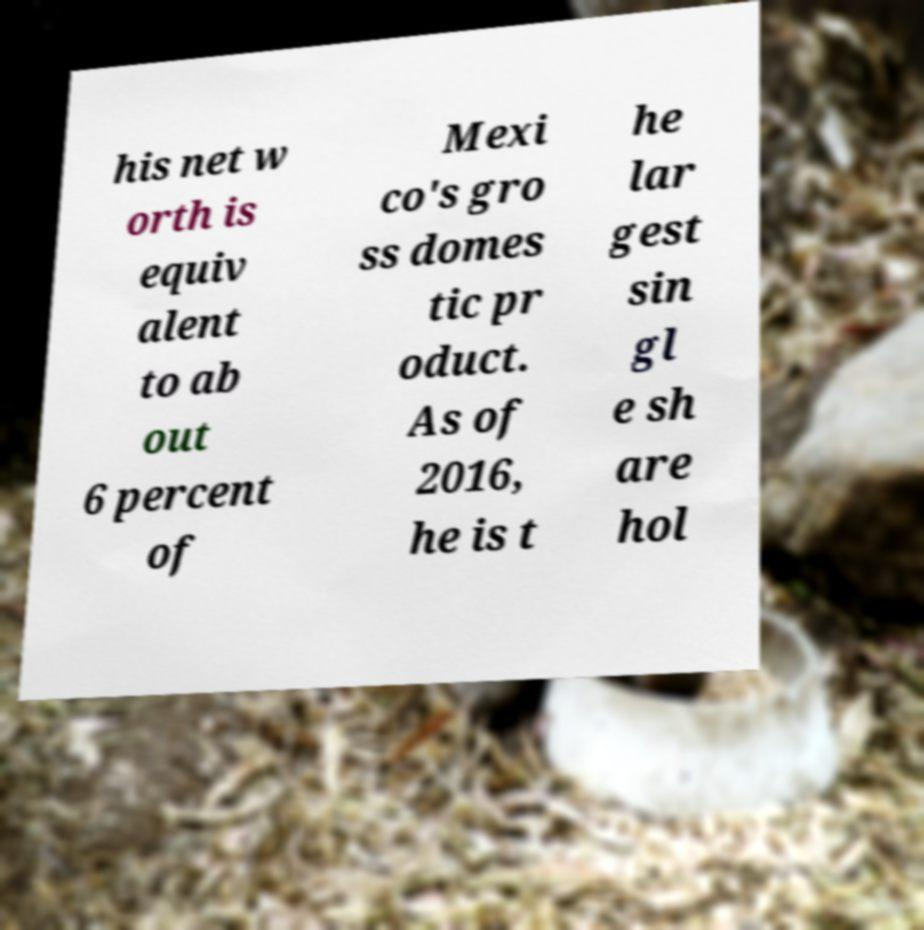Please read and relay the text visible in this image. What does it say? his net w orth is equiv alent to ab out 6 percent of Mexi co's gro ss domes tic pr oduct. As of 2016, he is t he lar gest sin gl e sh are hol 